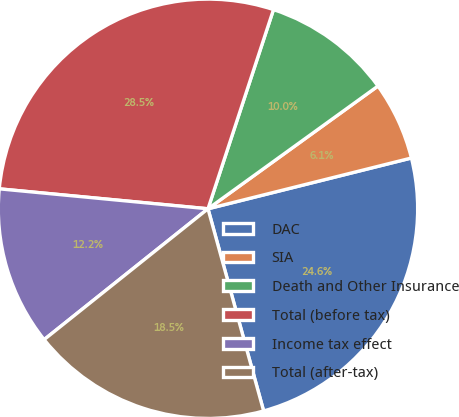Convert chart to OTSL. <chart><loc_0><loc_0><loc_500><loc_500><pie_chart><fcel>DAC<fcel>SIA<fcel>Death and Other Insurance<fcel>Total (before tax)<fcel>Income tax effect<fcel>Total (after-tax)<nl><fcel>24.62%<fcel>6.06%<fcel>9.99%<fcel>28.54%<fcel>12.24%<fcel>18.55%<nl></chart> 